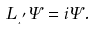Convert formula to latex. <formula><loc_0><loc_0><loc_500><loc_500>L _ { \xi ^ { \prime } } \Psi = i \Psi .</formula> 